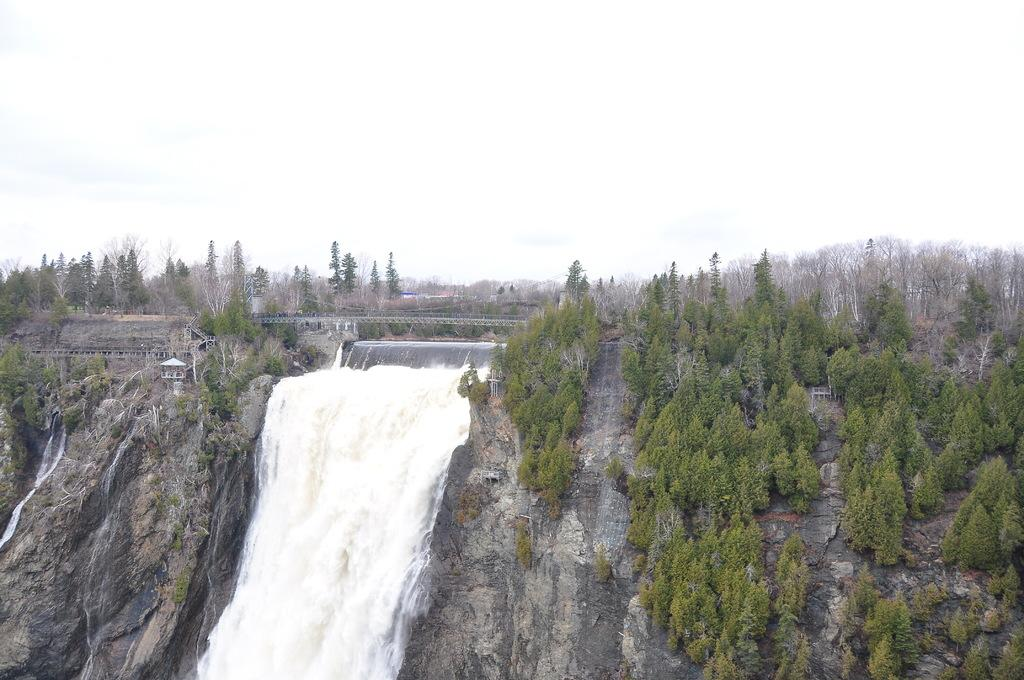What is happening with the water in the image? Water is falling from the mountains in the image. What can be seen in the background of the image? There are many trees in the background of the image. What is the color of the sky in the image? The sky is white in the image. How does the disgust factor contribute to the image? There is no mention of disgust in the image, as it features water falling from mountains, trees in the background, and a white sky. 